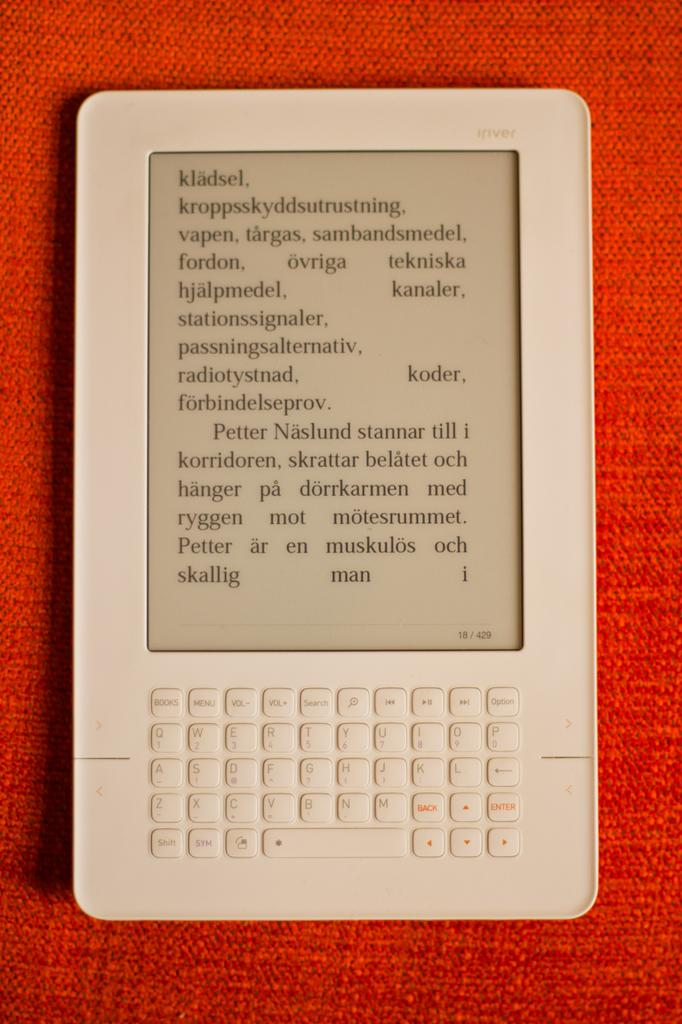<image>
Provide a brief description of the given image. a white table with words Kladsel Vapen and Ovriga on the screen 